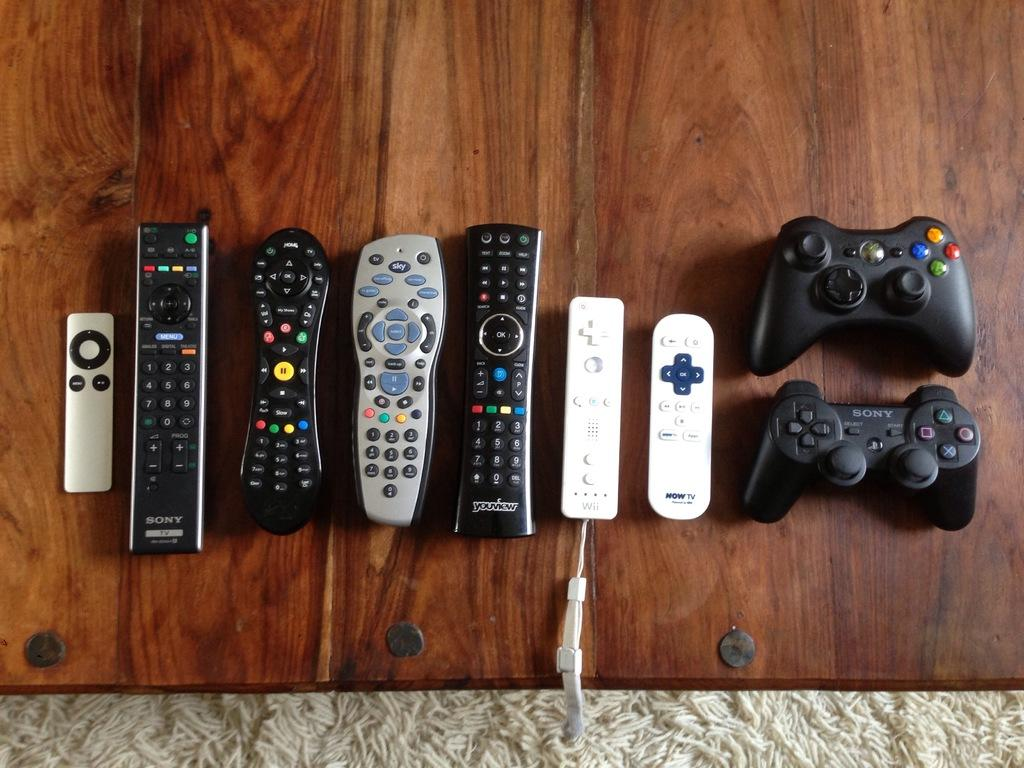<image>
Create a compact narrative representing the image presented. Several different remotes sit on a darkly colored wooden table including several by Sony. 